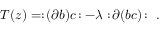Convert formula to latex. <formula><loc_0><loc_0><loc_500><loc_500>T ( z ) = \colon \, ( \partial b ) c \, \colon - \lambda \colon \, \partial ( b c ) \, \colon \ .</formula> 